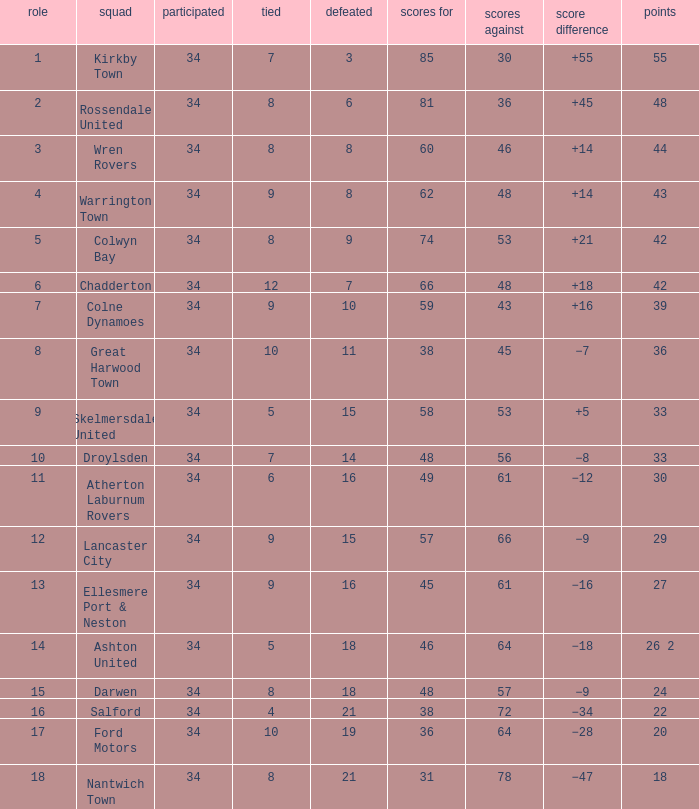What is the total number of goals for when the drawn is less than 7, less than 21 games have been lost, and there are 1 of 33 points? 1.0. 